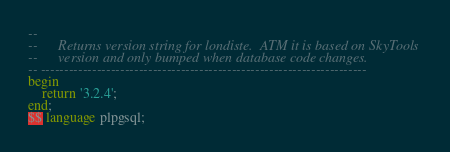<code> <loc_0><loc_0><loc_500><loc_500><_SQL_>--
--      Returns version string for londiste.  ATM it is based on SkyTools
--      version and only bumped when database code changes.
-- ----------------------------------------------------------------------
begin
    return '3.2.4';
end;
$$ language plpgsql;

</code> 